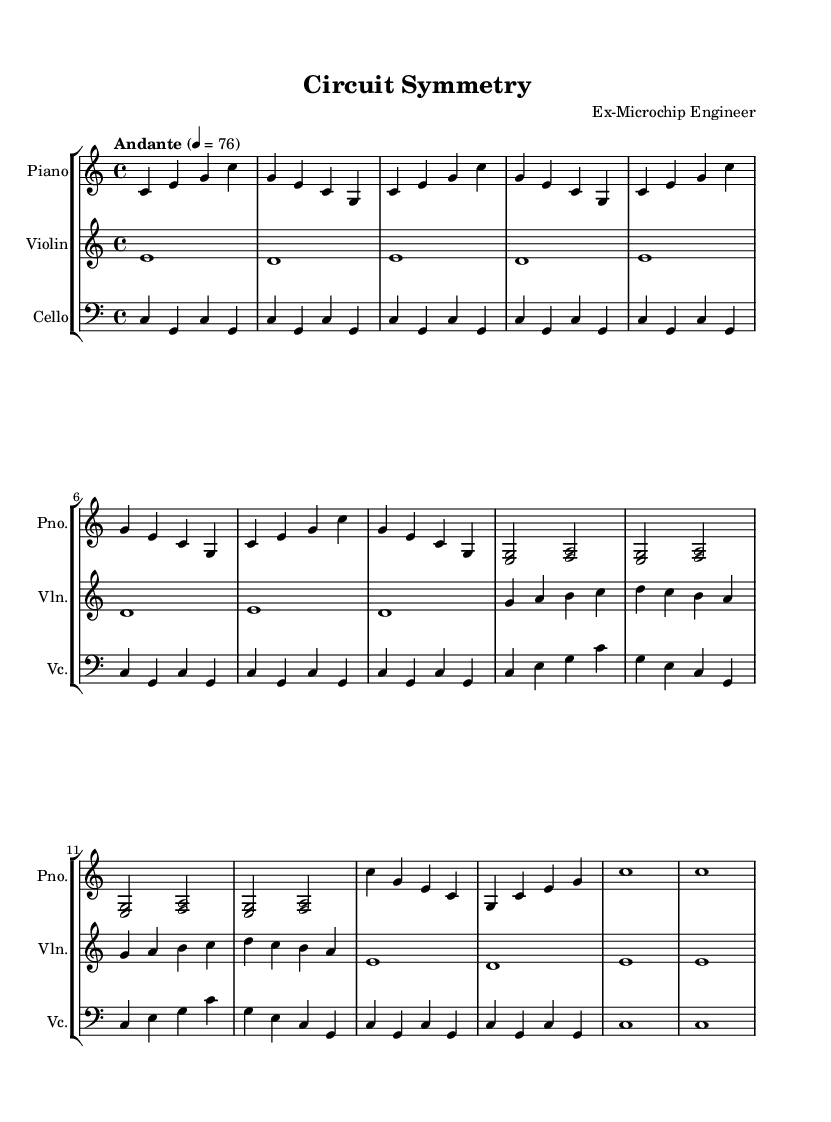What is the key signature of this music? The key signature is C major, which can be identified by the absence of sharps or flats indicated at the beginning of the staff.
Answer: C major What is the time signature of this piece? The time signature, shown at the beginning of the score, is 4/4, meaning there are four beats in each measure with the quarter note receiving one beat.
Answer: 4/4 What is the tempo marking for this piece? The tempo marking is indicated at the beginning of the score as "Andante," which generally refers to a moderately slow pace.
Answer: Andante How many measures are in the piano part? Counting the measures visually in the piano staff, there are 16 measures present before concluding the written music.
Answer: 16 In which clef is the cello part written? The cello part is written in the bass clef, which is indicated at the beginning of the cello staff and is typically used for lower-pitched instruments.
Answer: Bass clef What is the final note in the violin part? The last note in the violin part is an "e" which is found at the end of the part in the last measure.
Answer: E How many times is the motif 'c e g' repeated in the piano part? The motif 'c e g' appears eight times in the piano part, as evident from counting the measures where it is played.
Answer: 8 